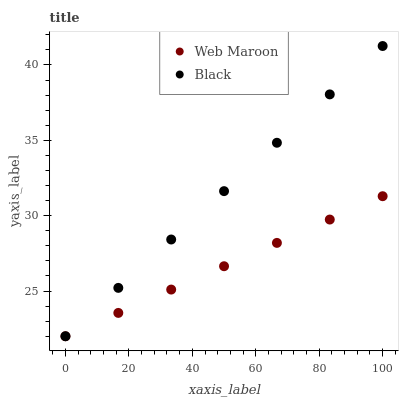Does Web Maroon have the minimum area under the curve?
Answer yes or no. Yes. Does Black have the maximum area under the curve?
Answer yes or no. Yes. Does Web Maroon have the maximum area under the curve?
Answer yes or no. No. Is Web Maroon the smoothest?
Answer yes or no. Yes. Is Black the roughest?
Answer yes or no. Yes. Is Web Maroon the roughest?
Answer yes or no. No. Does Black have the lowest value?
Answer yes or no. Yes. Does Black have the highest value?
Answer yes or no. Yes. Does Web Maroon have the highest value?
Answer yes or no. No. Does Web Maroon intersect Black?
Answer yes or no. Yes. Is Web Maroon less than Black?
Answer yes or no. No. Is Web Maroon greater than Black?
Answer yes or no. No. 